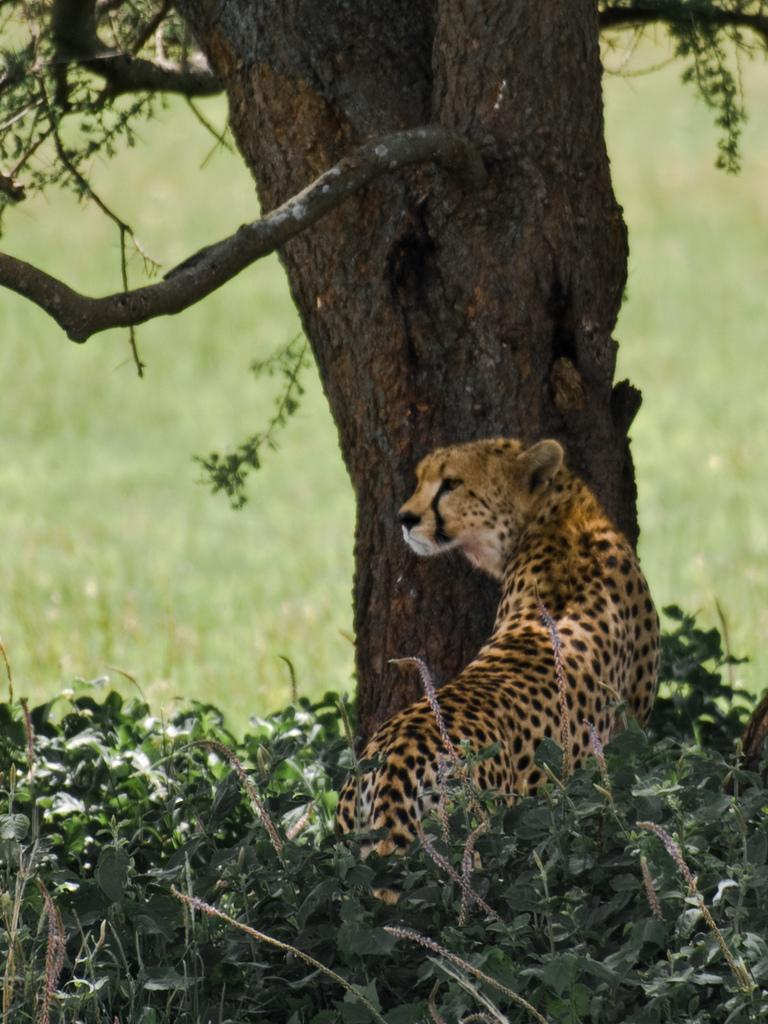What animal is in the center of the image? There is a cheetah in the center of the image. What object can be seen near the cheetah? There is a tree trunk in the image. What type of vegetation is visible in the background of the image? There is grass visible in the background of the image. What type of plants are at the bottom of the image? There are plants at the bottom of the image. How many eggs are visible in the image? There are no eggs visible in the image. 